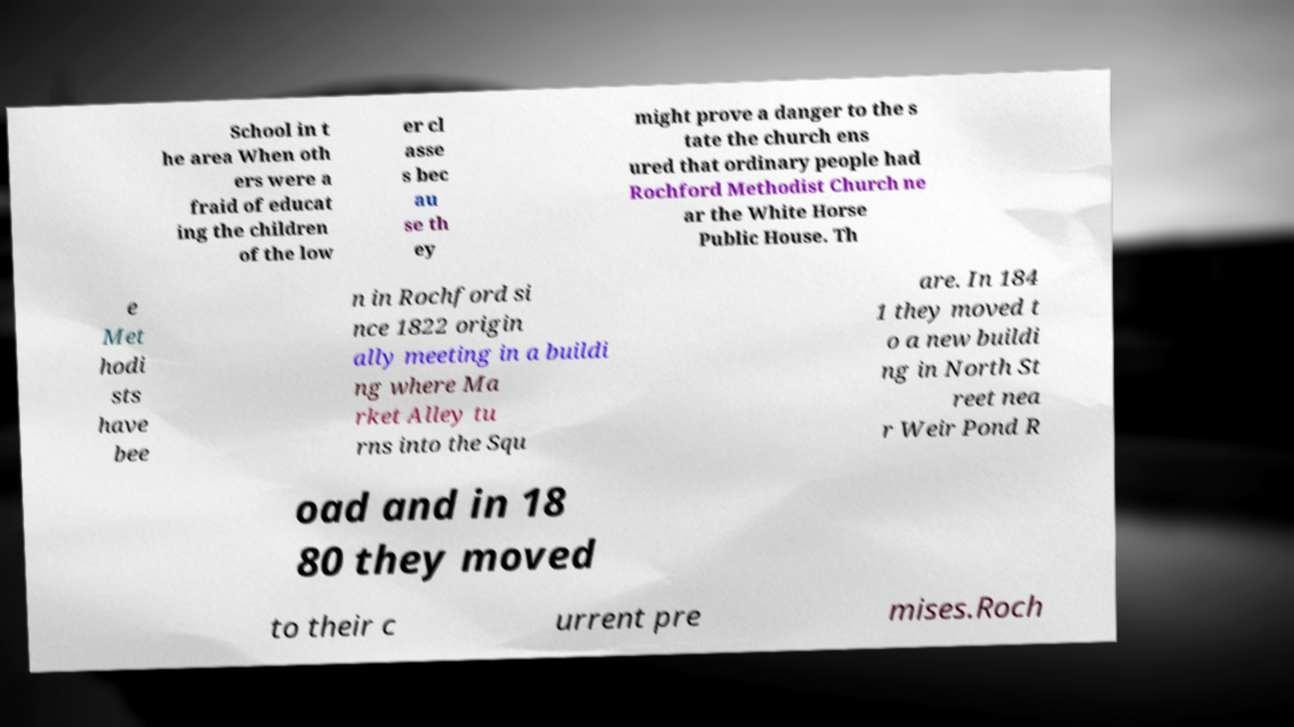Please identify and transcribe the text found in this image. School in t he area When oth ers were a fraid of educat ing the children of the low er cl asse s bec au se th ey might prove a danger to the s tate the church ens ured that ordinary people had Rochford Methodist Church ne ar the White Horse Public House. Th e Met hodi sts have bee n in Rochford si nce 1822 origin ally meeting in a buildi ng where Ma rket Alley tu rns into the Squ are. In 184 1 they moved t o a new buildi ng in North St reet nea r Weir Pond R oad and in 18 80 they moved to their c urrent pre mises.Roch 